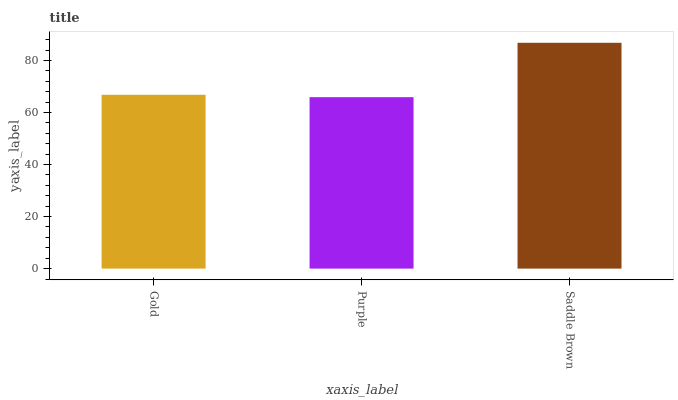Is Purple the minimum?
Answer yes or no. Yes. Is Saddle Brown the maximum?
Answer yes or no. Yes. Is Saddle Brown the minimum?
Answer yes or no. No. Is Purple the maximum?
Answer yes or no. No. Is Saddle Brown greater than Purple?
Answer yes or no. Yes. Is Purple less than Saddle Brown?
Answer yes or no. Yes. Is Purple greater than Saddle Brown?
Answer yes or no. No. Is Saddle Brown less than Purple?
Answer yes or no. No. Is Gold the high median?
Answer yes or no. Yes. Is Gold the low median?
Answer yes or no. Yes. Is Purple the high median?
Answer yes or no. No. Is Purple the low median?
Answer yes or no. No. 